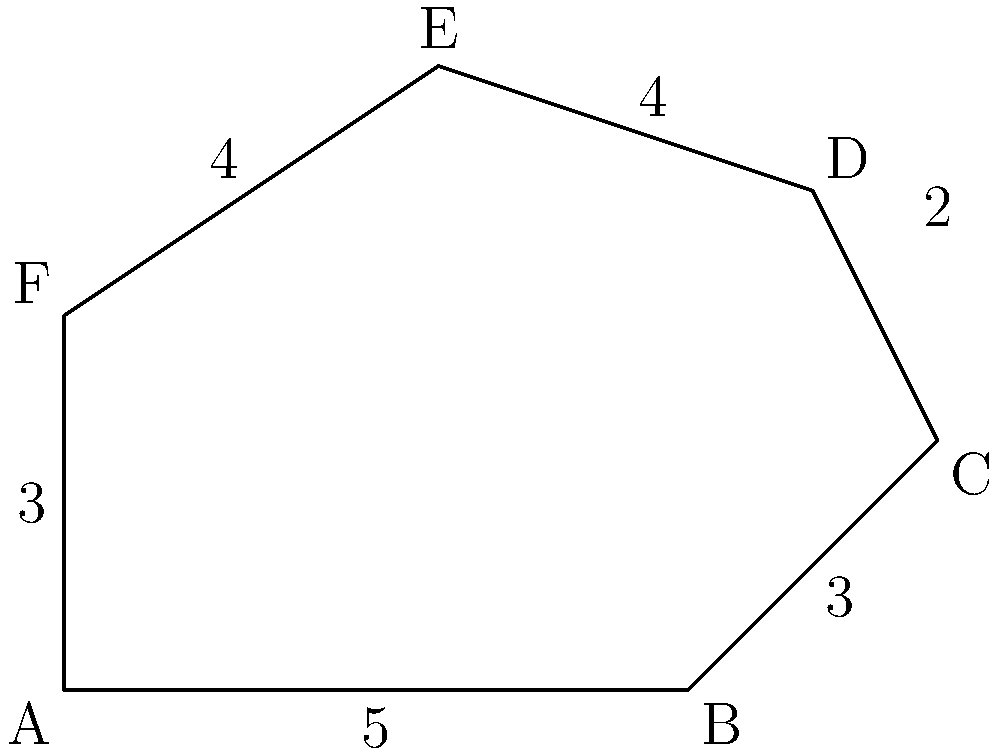The irregular hexagon ABCDEF represents the outline of the historic Plaza Independencia in Montevideo, a significant site in Uruguay's women's rights movement. If the measurements are in hundreds of meters, calculate the perimeter of the plaza. To find the perimeter of the irregular hexagon, we need to sum up the lengths of all its sides. Let's break it down step by step:

1. Side AB: $5$ hundred meters
2. Side BC: $3$ hundred meters
3. Side CD: $2$ hundred meters
4. Side DE: $4$ hundred meters
5. Side EF: $4$ hundred meters
6. Side FA: $3$ hundred meters

Now, let's add all these lengths:

$$\text{Perimeter} = 5 + 3 + 2 + 4 + 4 + 3 = 21$$

Therefore, the perimeter of the plaza is 21 hundred meters, or 2100 meters.
Answer: 2100 meters 